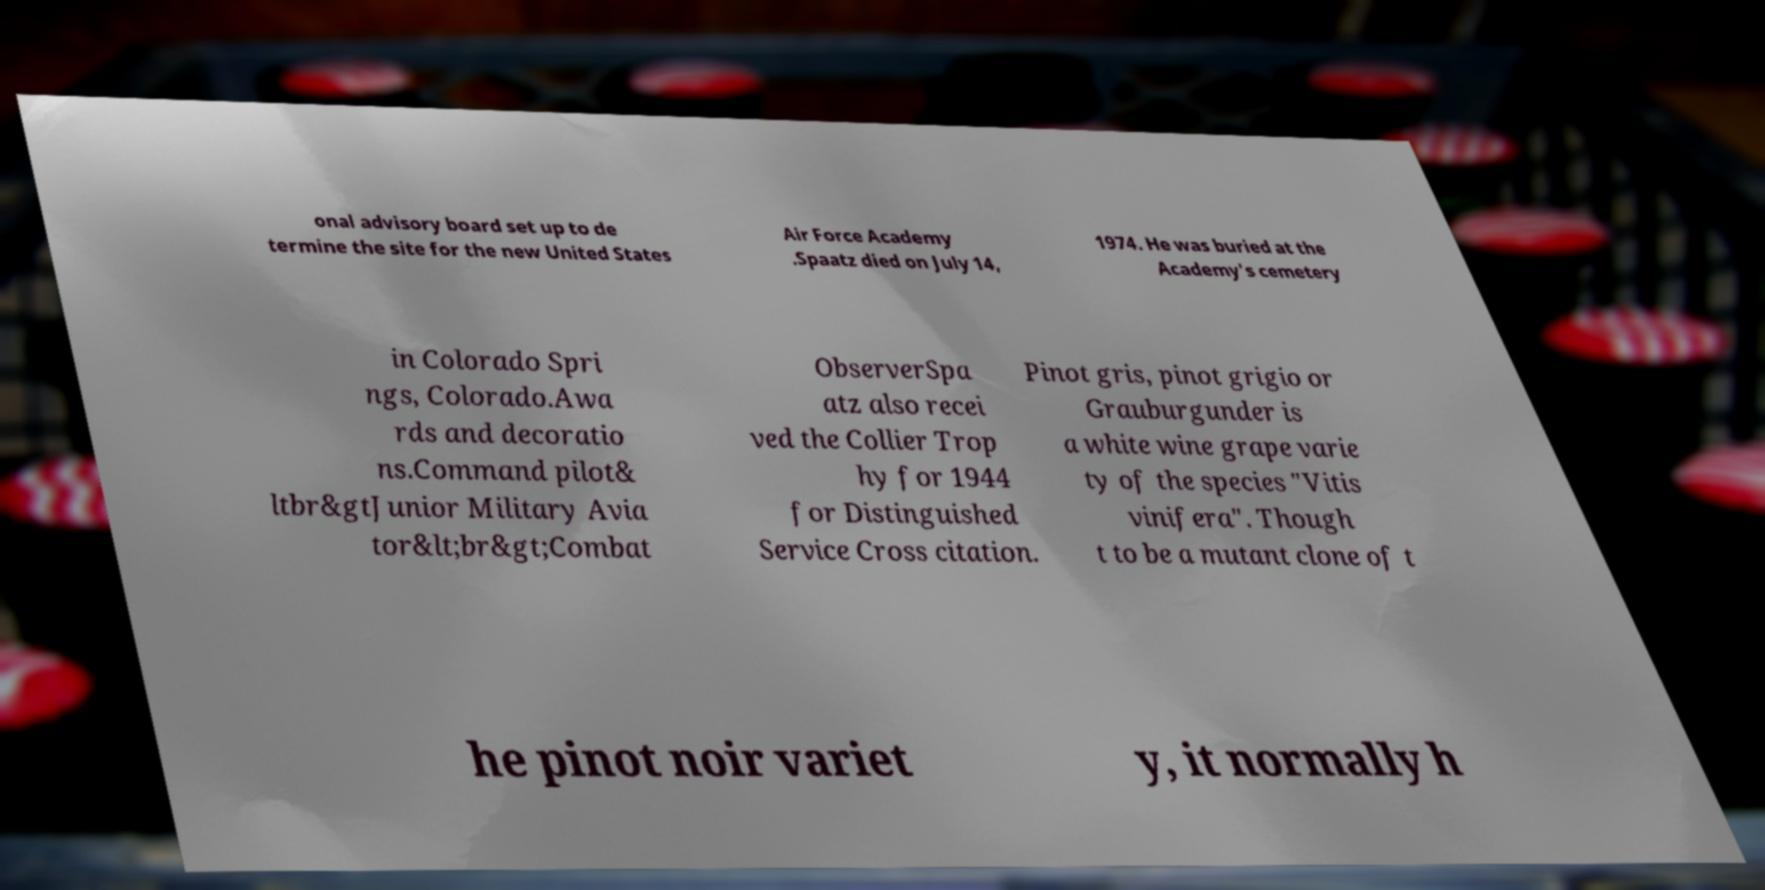There's text embedded in this image that I need extracted. Can you transcribe it verbatim? onal advisory board set up to de termine the site for the new United States Air Force Academy .Spaatz died on July 14, 1974. He was buried at the Academy's cemetery in Colorado Spri ngs, Colorado.Awa rds and decoratio ns.Command pilot& ltbr&gtJunior Military Avia tor&lt;br&gt;Combat ObserverSpa atz also recei ved the Collier Trop hy for 1944 for Distinguished Service Cross citation. Pinot gris, pinot grigio or Grauburgunder is a white wine grape varie ty of the species "Vitis vinifera". Though t to be a mutant clone of t he pinot noir variet y, it normally h 